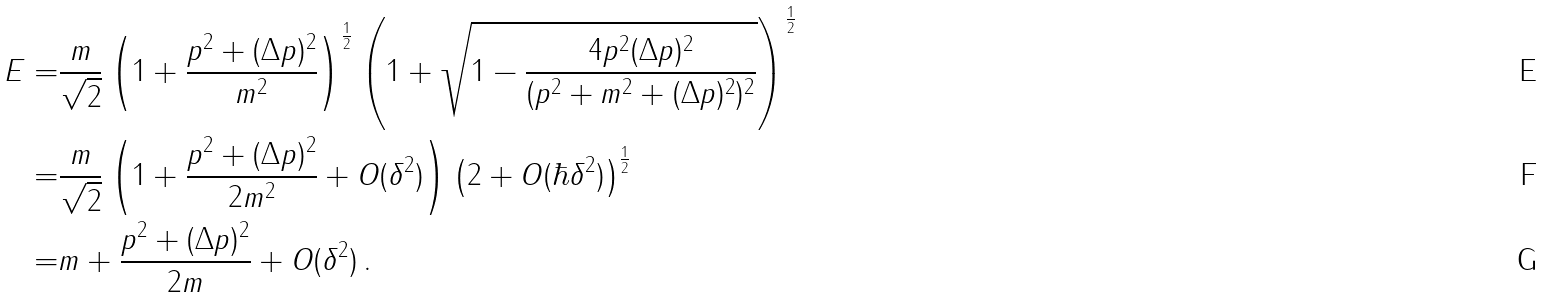<formula> <loc_0><loc_0><loc_500><loc_500>E = & \frac { m } { \sqrt { 2 } } \left ( 1 + \frac { p ^ { 2 } + ( \Delta p ) ^ { 2 } } { m ^ { 2 } } \right ) ^ { \frac { 1 } { 2 } } \left ( 1 + \sqrt { 1 - \frac { 4 p ^ { 2 } ( \Delta p ) ^ { 2 } } { ( p ^ { 2 } + m ^ { 2 } + ( \Delta p ) ^ { 2 } ) ^ { 2 } } } \right ) ^ { \frac { 1 } { 2 } } \\ = & \frac { m } { \sqrt { 2 } } \left ( 1 + \frac { p ^ { 2 } + ( \Delta p ) ^ { 2 } } { 2 m ^ { 2 } } + O ( \delta ^ { 2 } ) \right ) \left ( 2 + O ( \hbar { \delta } ^ { 2 } ) \right ) ^ { \frac { 1 } { 2 } } \\ = & m + \frac { p ^ { 2 } + ( \Delta p ) ^ { 2 } } { 2 m } + O ( \delta ^ { 2 } ) \, .</formula> 